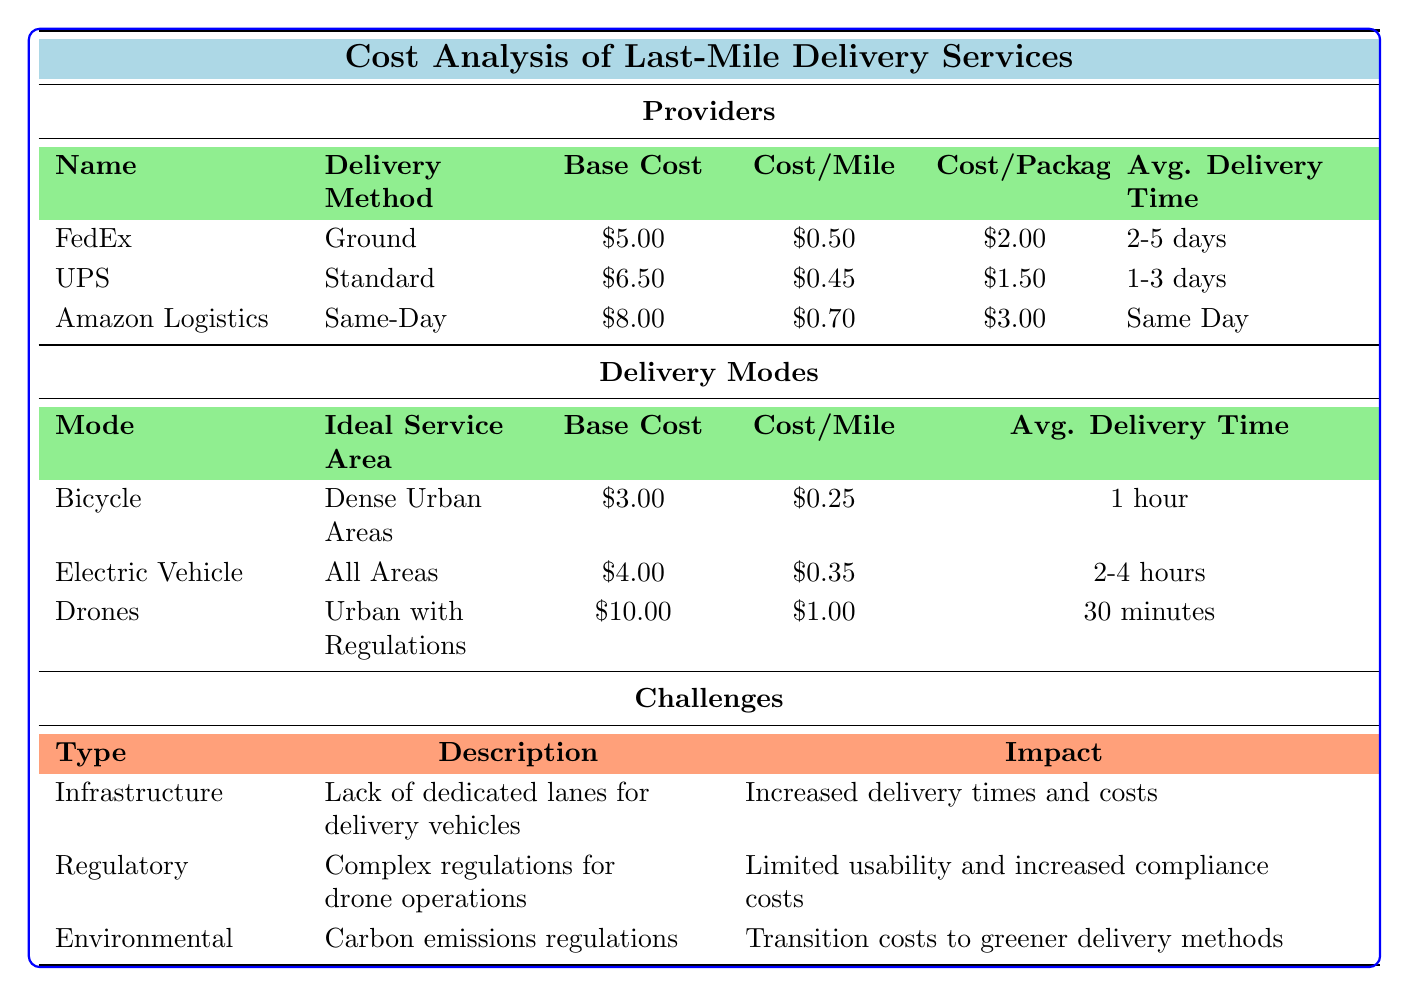What is the base cost of UPS delivery service? The table states that the base cost for UPS is listed directly under the Providers section. UPS shows a base cost of 6.50.
Answer: 6.50 Which delivery method has the highest cost per package? By examining the Cost per Package column in the Providers section of the table, Amazon Logistics is seen to have a cost of 3.00, which is higher than both FedEx (2.00) and UPS (1.50).
Answer: Amazon Logistics What is the average delivery time for Bicycle delivery mode? The Average Delivery Time column under the Delivery Modes section indicates that Bicycle delivery mode has an average delivery time of 1 hour as stated directly in the table.
Answer: 1 hour What is the total cost per mile for FedEx and UPS combined? The cost per mile for FedEx is 0.50 and for UPS is 0.45. Adding these two values together (0.50 + 0.45) results in 0.95.
Answer: 0.95 Is the delivery time for Drones shorter than that for Electric Vehicle delivery? Referring to the Average Delivery Time in the Delivery Modes section, Drones offer delivery in 30 minutes, while Electric Vehicles take 2-4 hours. Since 30 minutes is less than 2 hours, the statement is true.
Answer: Yes What is the ideal service area for Bicycle delivery mode? The Ideal Service Area for the Bicycle delivery mode is explicitly noted in the table under the Delivery Modes section as Dense Urban Areas.
Answer: Dense Urban Areas Are there dedicated lanes for delivery vehicles according to the challenges presented? The Infrastructure challenge section states "Lack of dedicated lanes for delivery vehicles," directly indicating that there are no such lanes available.
Answer: No Which delivery provider has the lowest base cost? The Providers section lists FedEx with a base cost of 5.00, UPS at 6.50, and Amazon Logistics at 8.00. Comparing these values shows that FedEx has the lowest base cost of the three providers.
Answer: FedEx What is the impact of carbon emissions regulations according to the challenges? Under the Environmental challenges, the impact of carbon emissions regulations is described as "Transition costs to greener delivery methods," which provides a clear view of the associated impact.
Answer: Transition costs to greener delivery methods 